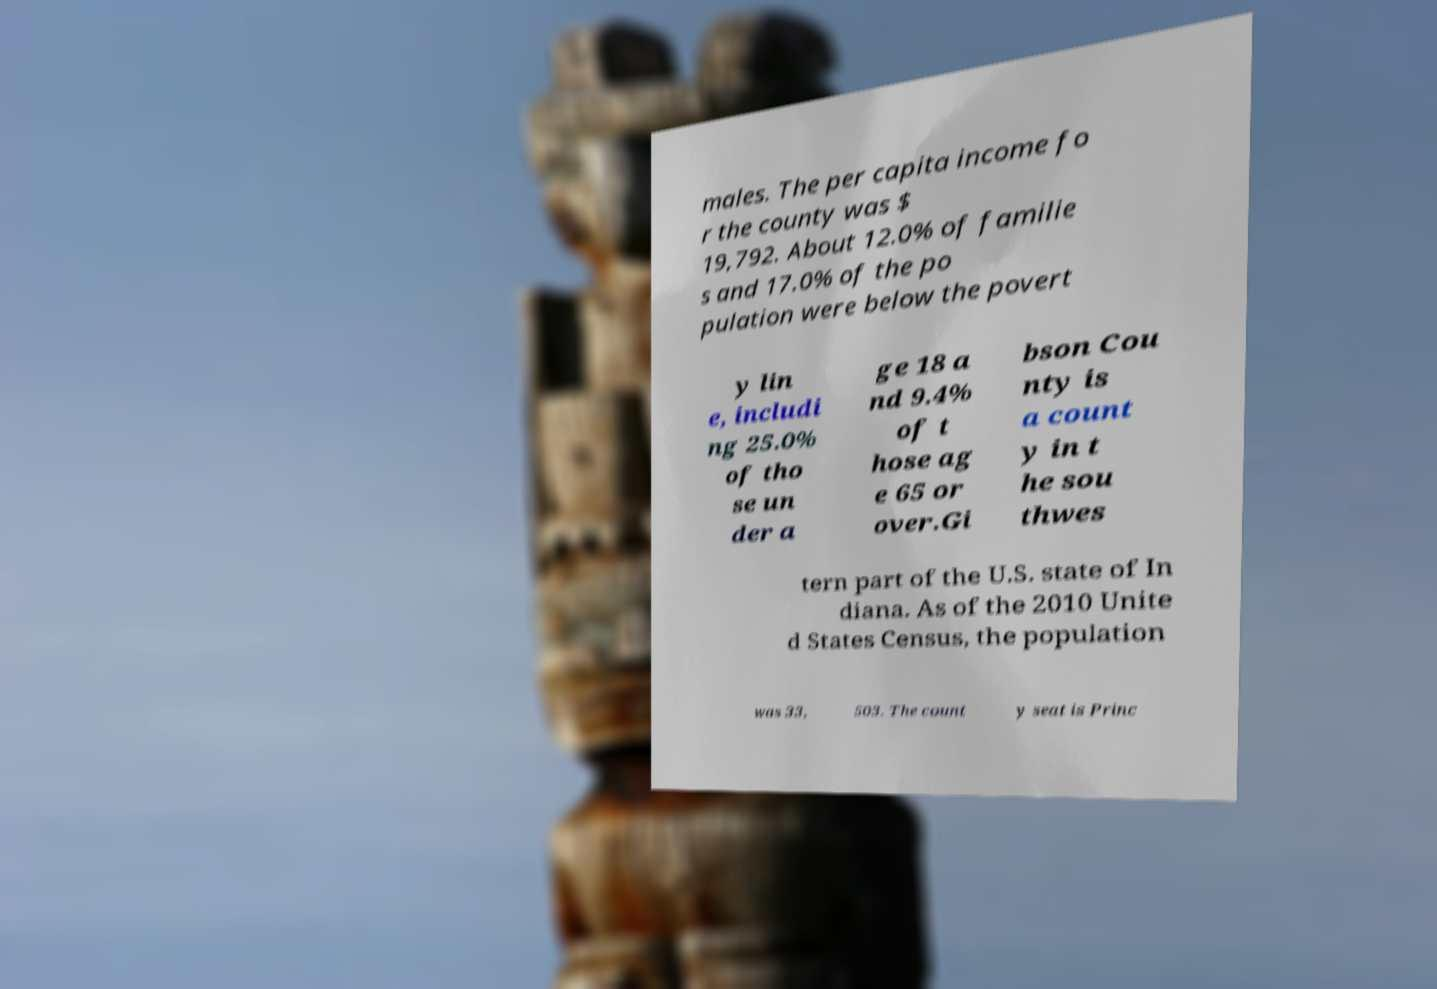Please identify and transcribe the text found in this image. males. The per capita income fo r the county was $ 19,792. About 12.0% of familie s and 17.0% of the po pulation were below the povert y lin e, includi ng 25.0% of tho se un der a ge 18 a nd 9.4% of t hose ag e 65 or over.Gi bson Cou nty is a count y in t he sou thwes tern part of the U.S. state of In diana. As of the 2010 Unite d States Census, the population was 33, 503. The count y seat is Princ 